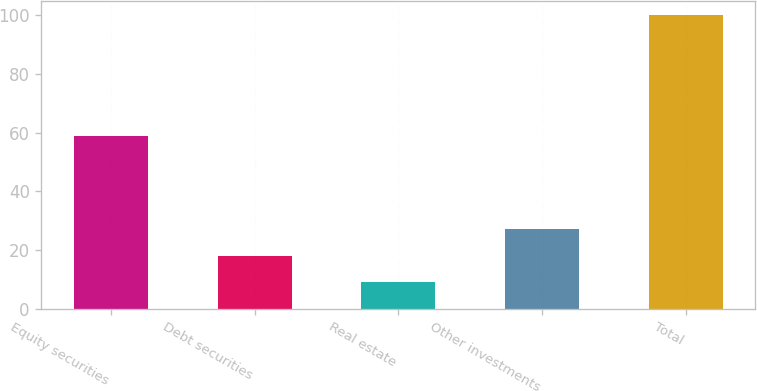Convert chart to OTSL. <chart><loc_0><loc_0><loc_500><loc_500><bar_chart><fcel>Equity securities<fcel>Debt securities<fcel>Real estate<fcel>Other investments<fcel>Total<nl><fcel>59<fcel>18.1<fcel>9<fcel>27.2<fcel>100<nl></chart> 